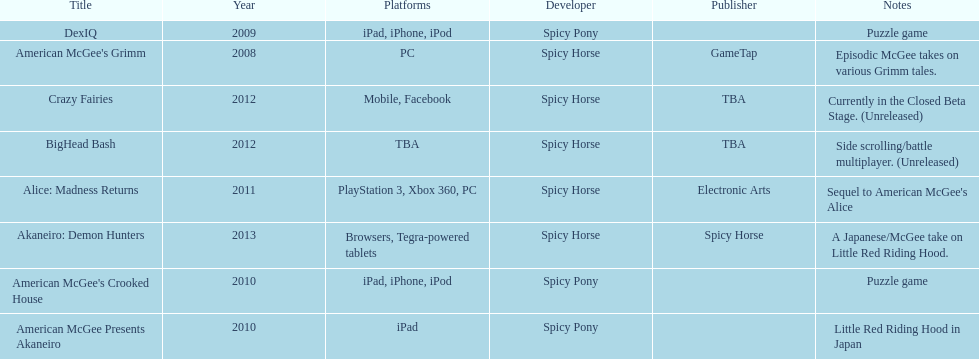Help me parse the entirety of this table. {'header': ['Title', 'Year', 'Platforms', 'Developer', 'Publisher', 'Notes'], 'rows': [['DexIQ', '2009', 'iPad, iPhone, iPod', 'Spicy Pony', '', 'Puzzle game'], ["American McGee's Grimm", '2008', 'PC', 'Spicy Horse', 'GameTap', 'Episodic McGee takes on various Grimm tales.'], ['Crazy Fairies', '2012', 'Mobile, Facebook', 'Spicy Horse', 'TBA', 'Currently in the Closed Beta Stage. (Unreleased)'], ['BigHead Bash', '2012', 'TBA', 'Spicy Horse', 'TBA', 'Side scrolling/battle multiplayer. (Unreleased)'], ['Alice: Madness Returns', '2011', 'PlayStation 3, Xbox 360, PC', 'Spicy Horse', 'Electronic Arts', "Sequel to American McGee's Alice"], ['Akaneiro: Demon Hunters', '2013', 'Browsers, Tegra-powered tablets', 'Spicy Horse', 'Spicy Horse', 'A Japanese/McGee take on Little Red Riding Hood.'], ["American McGee's Crooked House", '2010', 'iPad, iPhone, iPod', 'Spicy Pony', '', 'Puzzle game'], ['American McGee Presents Akaneiro', '2010', 'iPad', 'Spicy Pony', '', 'Little Red Riding Hood in Japan']]} How many platforms did american mcgee's grimm run on? 1. 